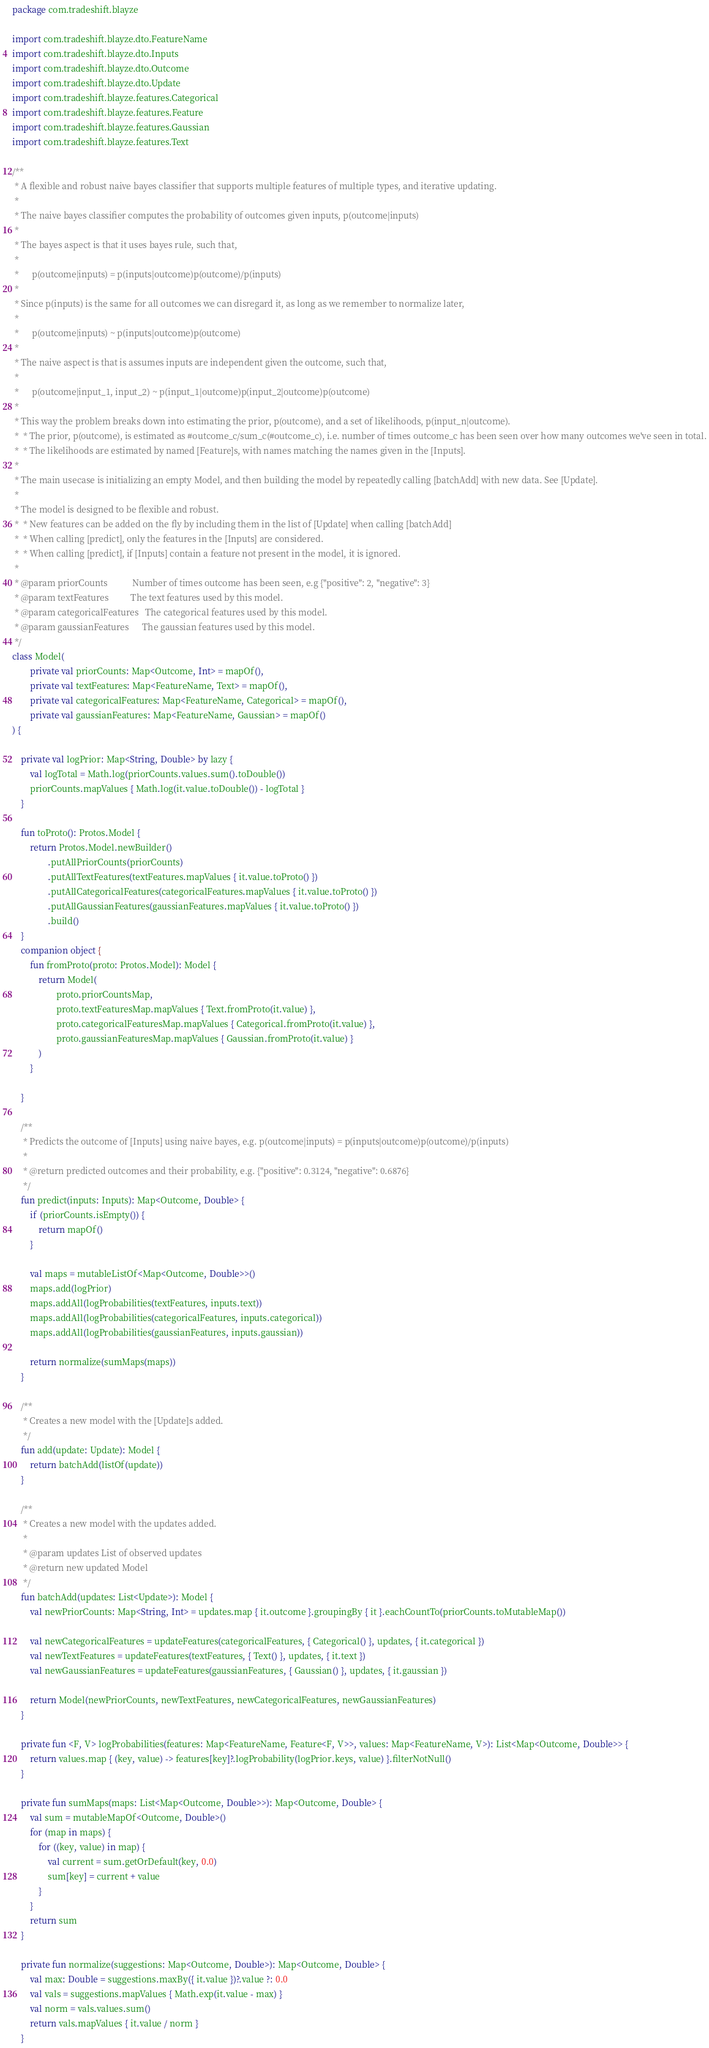<code> <loc_0><loc_0><loc_500><loc_500><_Kotlin_>package com.tradeshift.blayze

import com.tradeshift.blayze.dto.FeatureName
import com.tradeshift.blayze.dto.Inputs
import com.tradeshift.blayze.dto.Outcome
import com.tradeshift.blayze.dto.Update
import com.tradeshift.blayze.features.Categorical
import com.tradeshift.blayze.features.Feature
import com.tradeshift.blayze.features.Gaussian
import com.tradeshift.blayze.features.Text

/**
 * A flexible and robust naive bayes classifier that supports multiple features of multiple types, and iterative updating.
 *
 * The naive bayes classifier computes the probability of outcomes given inputs, p(outcome|inputs)
 *
 * The bayes aspect is that it uses bayes rule, such that,
 *
 *      p(outcome|inputs) = p(inputs|outcome)p(outcome)/p(inputs)
 *
 * Since p(inputs) is the same for all outcomes we can disregard it, as long as we remember to normalize later,
 *
 *      p(outcome|inputs) ~ p(inputs|outcome)p(outcome)
 *
 * The naive aspect is that is assumes inputs are independent given the outcome, such that,
 *
 *      p(outcome|input_1, input_2) ~ p(input_1|outcome)p(input_2|outcome)p(outcome)
 *
 * This way the problem breaks down into estimating the prior, p(outcome), and a set of likelihoods, p(input_n|outcome).
 *  * The prior, p(outcome), is estimated as #outcome_c/sum_c(#outcome_c), i.e. number of times outcome_c has been seen over how many outcomes we've seen in total.
 *  * The likelihoods are estimated by named [Feature]s, with names matching the names given in the [Inputs].
 *
 * The main usecase is initializing an empty Model, and then building the model by repeatedly calling [batchAdd] with new data. See [Update].
 *
 * The model is designed to be flexible and robust.
 *  * New features can be added on the fly by including them in the list of [Update] when calling [batchAdd]
 *  * When calling [predict], only the features in the [Inputs] are considered.
 *  * When calling [predict], if [Inputs] contain a feature not present in the model, it is ignored.
 *
 * @param priorCounts           Number of times outcome has been seen, e.g {"positive": 2, "negative": 3}
 * @param textFeatures          The text features used by this model.
 * @param categoricalFeatures   The categorical features used by this model.
 * @param gaussianFeatures      The gaussian features used by this model.
 */
class Model(
        private val priorCounts: Map<Outcome, Int> = mapOf(),
        private val textFeatures: Map<FeatureName, Text> = mapOf(),
        private val categoricalFeatures: Map<FeatureName, Categorical> = mapOf(),
        private val gaussianFeatures: Map<FeatureName, Gaussian> = mapOf()
) {

    private val logPrior: Map<String, Double> by lazy {
        val logTotal = Math.log(priorCounts.values.sum().toDouble())
        priorCounts.mapValues { Math.log(it.value.toDouble()) - logTotal }
    }

    fun toProto(): Protos.Model {
        return Protos.Model.newBuilder()
                .putAllPriorCounts(priorCounts)
                .putAllTextFeatures(textFeatures.mapValues { it.value.toProto() })
                .putAllCategoricalFeatures(categoricalFeatures.mapValues { it.value.toProto() })
                .putAllGaussianFeatures(gaussianFeatures.mapValues { it.value.toProto() })
                .build()
    }
    companion object {
        fun fromProto(proto: Protos.Model): Model {
            return Model(
                    proto.priorCountsMap,
                    proto.textFeaturesMap.mapValues { Text.fromProto(it.value) },
                    proto.categoricalFeaturesMap.mapValues { Categorical.fromProto(it.value) },
                    proto.gaussianFeaturesMap.mapValues { Gaussian.fromProto(it.value) }
            )
        }

    }

    /**
     * Predicts the outcome of [Inputs] using naive bayes, e.g. p(outcome|inputs) = p(inputs|outcome)p(outcome)/p(inputs)
     *
     * @return predicted outcomes and their probability, e.g. {"positive": 0.3124, "negative": 0.6876}
     */
    fun predict(inputs: Inputs): Map<Outcome, Double> {
        if (priorCounts.isEmpty()) {
            return mapOf()
        }

        val maps = mutableListOf<Map<Outcome, Double>>()
        maps.add(logPrior)
        maps.addAll(logProbabilities(textFeatures, inputs.text))
        maps.addAll(logProbabilities(categoricalFeatures, inputs.categorical))
        maps.addAll(logProbabilities(gaussianFeatures, inputs.gaussian))

        return normalize(sumMaps(maps))
    }

    /**
     * Creates a new model with the [Update]s added.
     */
    fun add(update: Update): Model {
        return batchAdd(listOf(update))
    }

    /**
     * Creates a new model with the updates added.
     *
     * @param updates List of observed updates
     * @return new updated Model
     */
    fun batchAdd(updates: List<Update>): Model {
        val newPriorCounts: Map<String, Int> = updates.map { it.outcome }.groupingBy { it }.eachCountTo(priorCounts.toMutableMap())

        val newCategoricalFeatures = updateFeatures(categoricalFeatures, { Categorical() }, updates, { it.categorical })
        val newTextFeatures = updateFeatures(textFeatures, { Text() }, updates, { it.text })
        val newGaussianFeatures = updateFeatures(gaussianFeatures, { Gaussian() }, updates, { it.gaussian })

        return Model(newPriorCounts, newTextFeatures, newCategoricalFeatures, newGaussianFeatures)
    }

    private fun <F, V> logProbabilities(features: Map<FeatureName, Feature<F, V>>, values: Map<FeatureName, V>): List<Map<Outcome, Double>> {
        return values.map { (key, value) -> features[key]?.logProbability(logPrior.keys, value) }.filterNotNull()
    }

    private fun sumMaps(maps: List<Map<Outcome, Double>>): Map<Outcome, Double> {
        val sum = mutableMapOf<Outcome, Double>()
        for (map in maps) {
            for ((key, value) in map) {
                val current = sum.getOrDefault(key, 0.0)
                sum[key] = current + value
            }
        }
        return sum
    }

    private fun normalize(suggestions: Map<Outcome, Double>): Map<Outcome, Double> {
        val max: Double = suggestions.maxBy({ it.value })?.value ?: 0.0
        val vals = suggestions.mapValues { Math.exp(it.value - max) }
        val norm = vals.values.sum()
        return vals.mapValues { it.value / norm }
    }

</code> 